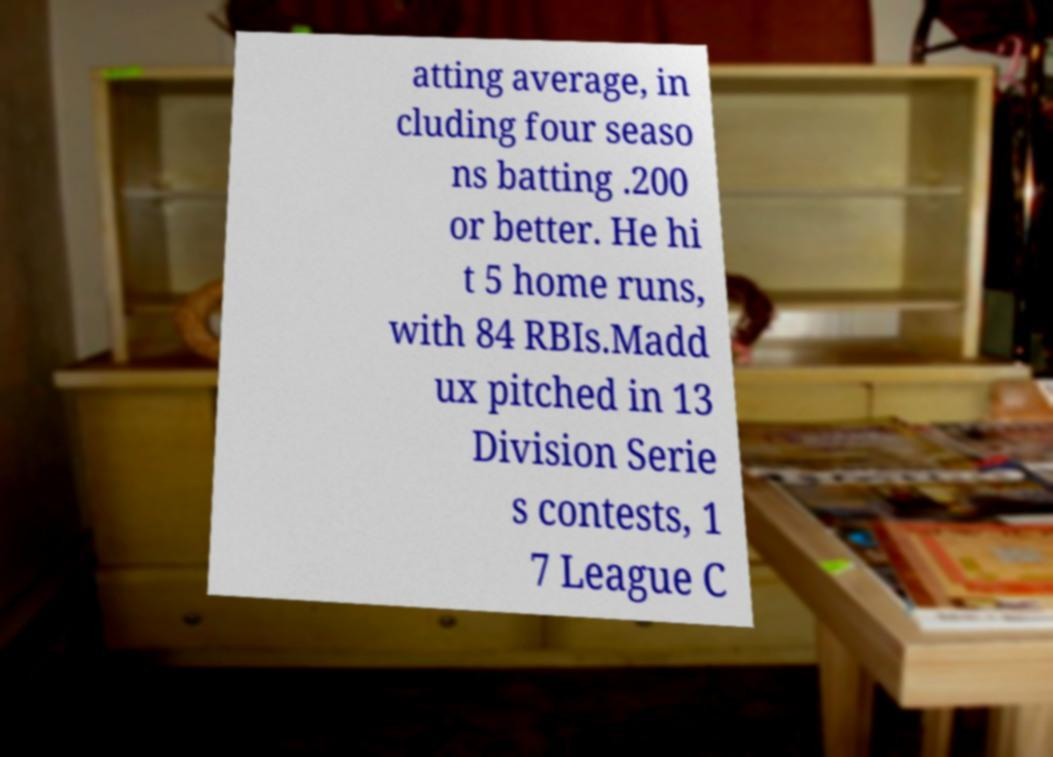What messages or text are displayed in this image? I need them in a readable, typed format. atting average, in cluding four seaso ns batting .200 or better. He hi t 5 home runs, with 84 RBIs.Madd ux pitched in 13 Division Serie s contests, 1 7 League C 